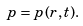<formula> <loc_0><loc_0><loc_500><loc_500>p = p ( r , t ) .</formula> 